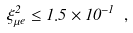Convert formula to latex. <formula><loc_0><loc_0><loc_500><loc_500>\xi _ { \mu e } ^ { 2 } \leq 1 . 5 \times 1 0 ^ { - 1 } \ ,</formula> 